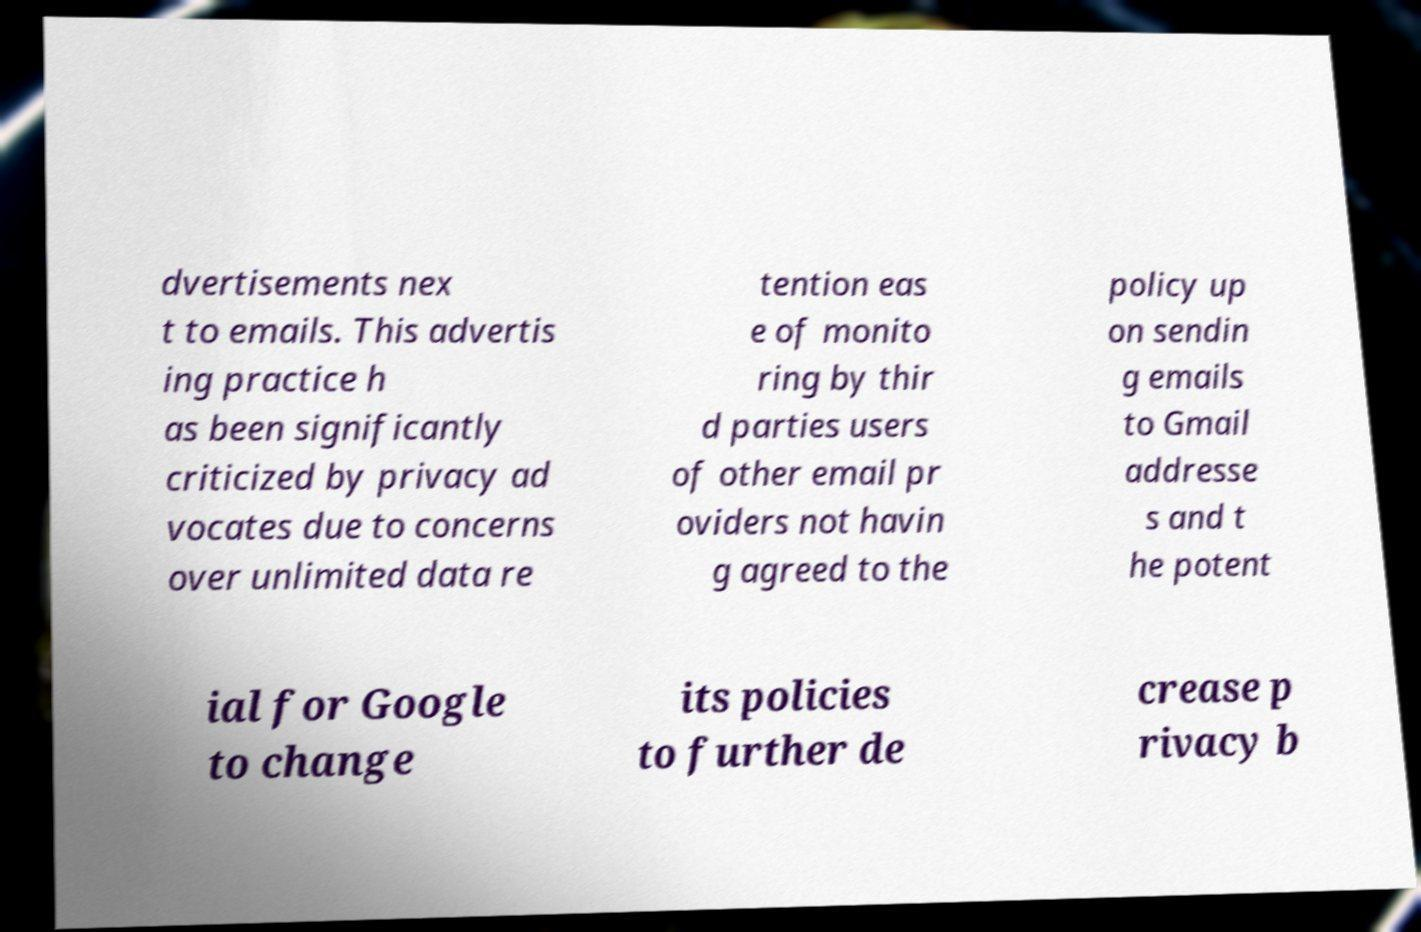For documentation purposes, I need the text within this image transcribed. Could you provide that? dvertisements nex t to emails. This advertis ing practice h as been significantly criticized by privacy ad vocates due to concerns over unlimited data re tention eas e of monito ring by thir d parties users of other email pr oviders not havin g agreed to the policy up on sendin g emails to Gmail addresse s and t he potent ial for Google to change its policies to further de crease p rivacy b 